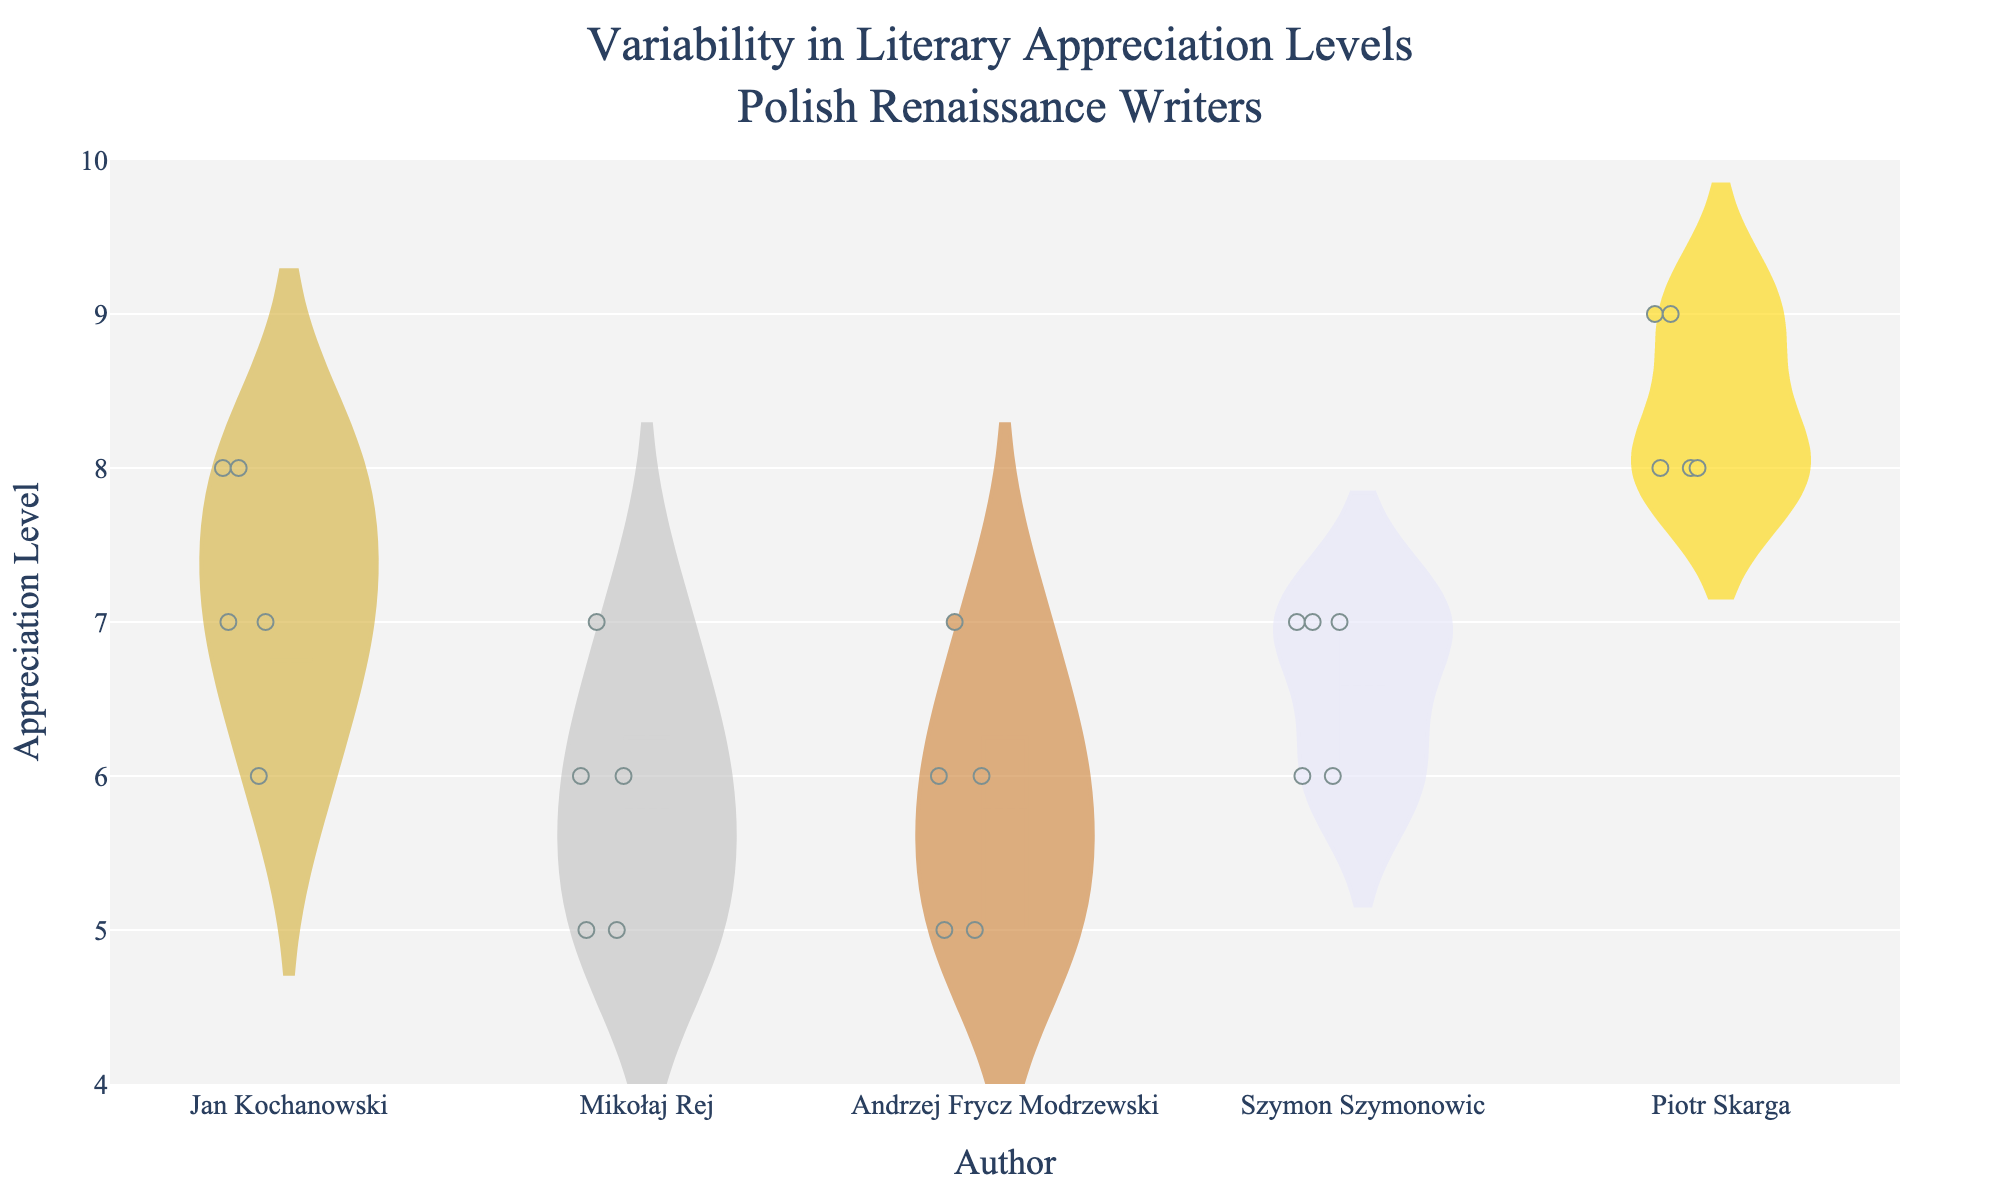What is the title of the violin chart? The title is positioned at the top of the figure and provides an overview of the chart’s content. Refer to the center-top text within the figure.
Answer: Variability in Literary Appreciation Levels: Polish Renaissance Writers Which author's works show the widest range of appreciation levels? By examining the spread of values in the violin plots for each author, we notice which plot spans the greatest range on the y-axis.
Answer: Jan Kochanowski Which author has the highest median appreciation level? Each violin plot includes a line representing the median. By comparing the height of these median lines across all authors, the highest one belongs to one specific author.
Answer: Piotr Skarga How many appreciation levels are there for Jan Kochanowski? Count the distinct points in the violin plot for Jan Kochanowski shown on the chart to determine the variety of appreciation levels.
Answer: 3 (6, 7, 8) What is the average appreciation level for Szymon Szymonowic's works? The average is computed by summing all appreciation levels for Szymon Szymonowic and dividing by their number: (6+7+7+6+7)/5.
Answer: 6.6 Which author has the smallest variability in appreciation levels? By evaluating the relative width and spread of the violin plots, the tightest plot represents the smallest variability.
Answer: Piotr Skarga What appreciation level appears most frequently for Mikołaj Rej? The density and peak height in the violin plot for Mikołaj Rej indicate which level is most common.
Answer: 5 and 6 Compare the median appreciation levels of Andrzej Frycz Modrzewski and Szymon Szymonowic. Locate and compare the median lines of the violin plots for these authors to determine which is higher.
Answer: Andrzej Frycz Modrzewski: 6, Szymon Szymonowic: 7 Which author’s works have appreciation levels closest to the middle of the given range (4 to 10)? Examine the average positions of the points and median lines within the violin plots, focusing on those authors whose data points cluster around the midpoint of the y-axis.
Answer: Andrzej Frycz Modrzewski How does the variability in appreciation levels for Mikołaj Rej compare to Szymon Szymonowic? Compare the width and spread of the violin plots for Mikołaj Rej and Szymon Szymonowic to assess their relative variability.
Answer: Szymon Szymonowic's variability is slightly more constrained than Mikołaj Rej's 